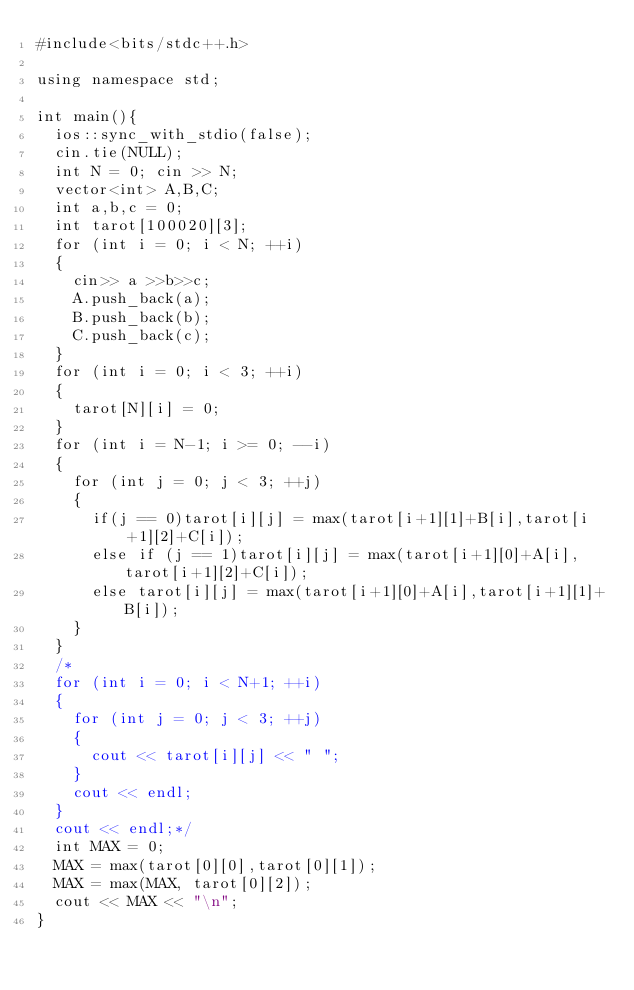Convert code to text. <code><loc_0><loc_0><loc_500><loc_500><_C++_>#include<bits/stdc++.h>

using namespace std;

int main(){
	ios::sync_with_stdio(false);
	cin.tie(NULL);
	int N = 0; cin >> N;
	vector<int> A,B,C;
	int a,b,c = 0;
	int tarot[100020][3];
	for (int i = 0; i < N; ++i)
	{
		cin>> a >>b>>c;
		A.push_back(a);
		B.push_back(b);
		C.push_back(c);
	}
	for (int i = 0; i < 3; ++i)
	{
		tarot[N][i] = 0;
	}
	for (int i = N-1; i >= 0; --i)
	{
		for (int j = 0; j < 3; ++j)
		{
			if(j == 0)tarot[i][j] = max(tarot[i+1][1]+B[i],tarot[i+1][2]+C[i]);
			else if (j == 1)tarot[i][j] = max(tarot[i+1][0]+A[i],tarot[i+1][2]+C[i]);
			else tarot[i][j] = max(tarot[i+1][0]+A[i],tarot[i+1][1]+B[i]);
		}
	}
	/*
	for (int i = 0; i < N+1; ++i)
	{
		for (int j = 0; j < 3; ++j)
		{
			cout << tarot[i][j] << " ";
		}
		cout << endl;
	}
	cout << endl;*/
	int MAX = 0;
	MAX = max(tarot[0][0],tarot[0][1]);
	MAX = max(MAX, tarot[0][2]);
	cout << MAX << "\n";
}	
</code> 